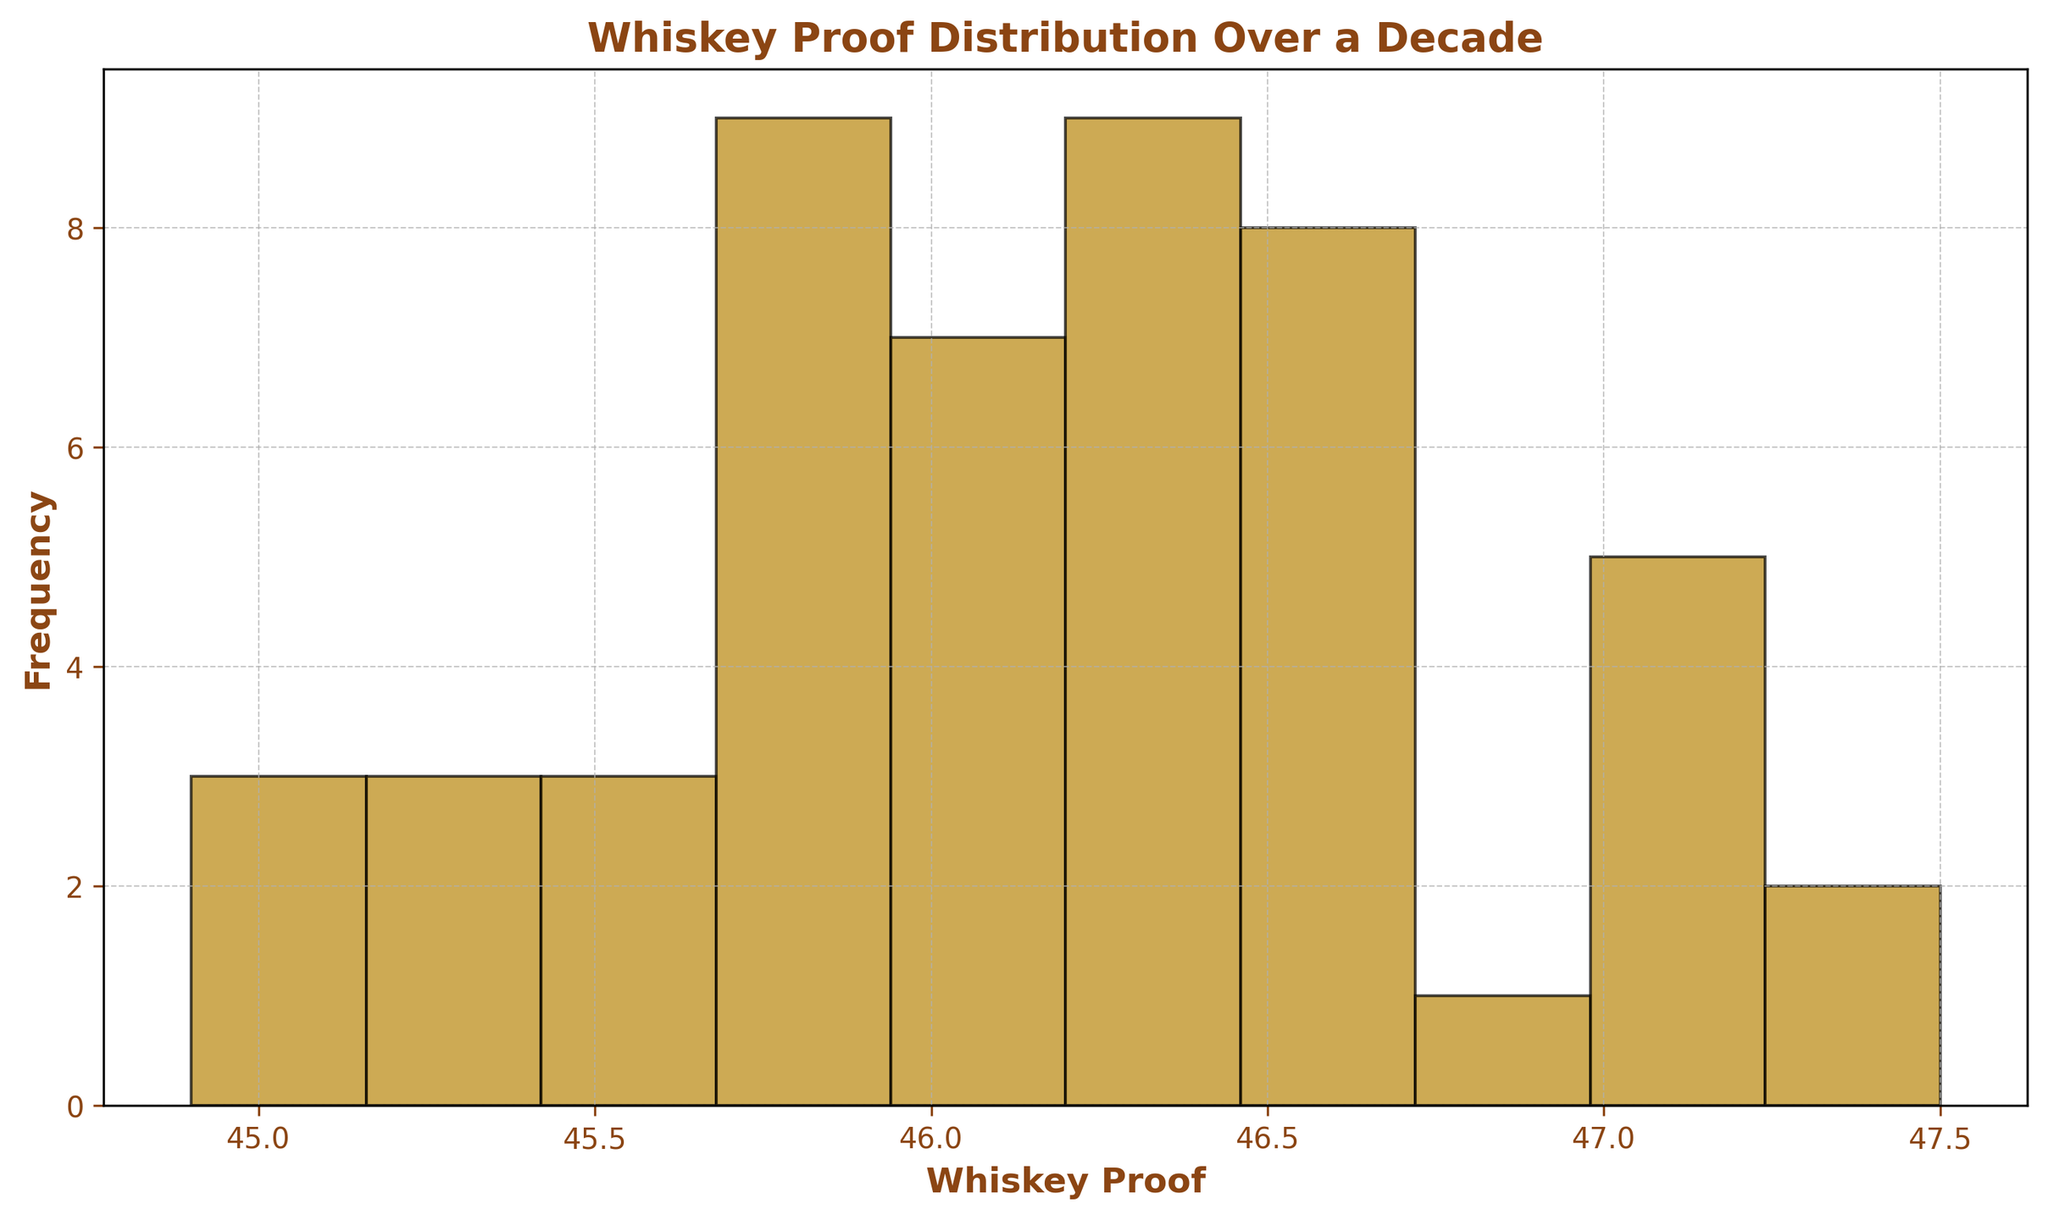What is the most frequent whiskey proof range? By observing the histogram, find the range with the highest bar, indicating the most frequent data points. Bins with the tallest bar represent the most common whiskey proof range.
Answer: 46.0-46.5 Which whiskey proof range appears least frequently in the data? By looking at the histogram, identify the range with the shortest bar. The bins with the shortest bar represent the least frequent occurrences of whiskey proof.
Answer: 44.5-45.0 What is the range of whiskey proofs displayed in the histogram? Notice the lowest and highest whiskey proof values on the x-axis of the histogram. This visually represents the range of whiskey proofs.
Answer: 44.5-47.5 Comparing the whiskey proofs, does the range of 46.0-46.5 have more occurrences than 45.5-46.0? View the height of the bars for the ranges 46.0-46.5 and 45.5-46.0. If the bar for 46.0-46.5 is taller, it means there are more instances in that range.
Answer: Yes How many bars show the whiskey proof distribution? Count the number of bars displayed on the histogram that represent the distinct ranges of whiskey proof.
Answer: 10 What percentage of the data points fall within the range 46.0-46.5? Identify the number of data points within the 46.0-46.5 range by looking at the frequency. Then calculate the percentage by dividing this by the total number of data points and multiplying by 100. For instance, if there are 20 data points overall and 8 fall within 46.0-46.5, the percentage is (8/20)*100.
Answer: 20/50 * 100 = 40% Comparing visual attributes, is the bar representing the 45.5-46.0 range taller than the bar representing the 45.0-45.5 range? Observe the height of the bars corresponding to the ranges 45.5-46.0 and 45.0-45.5. If the bar for 45.5-46.0 is higher, it is taller.
Answer: Yes Does the histogram have a symmetrical distribution? Symmetrical histograms have bars of equal height mirroring on either side of a central point. Inspect the histogram for this property.
Answer: No 